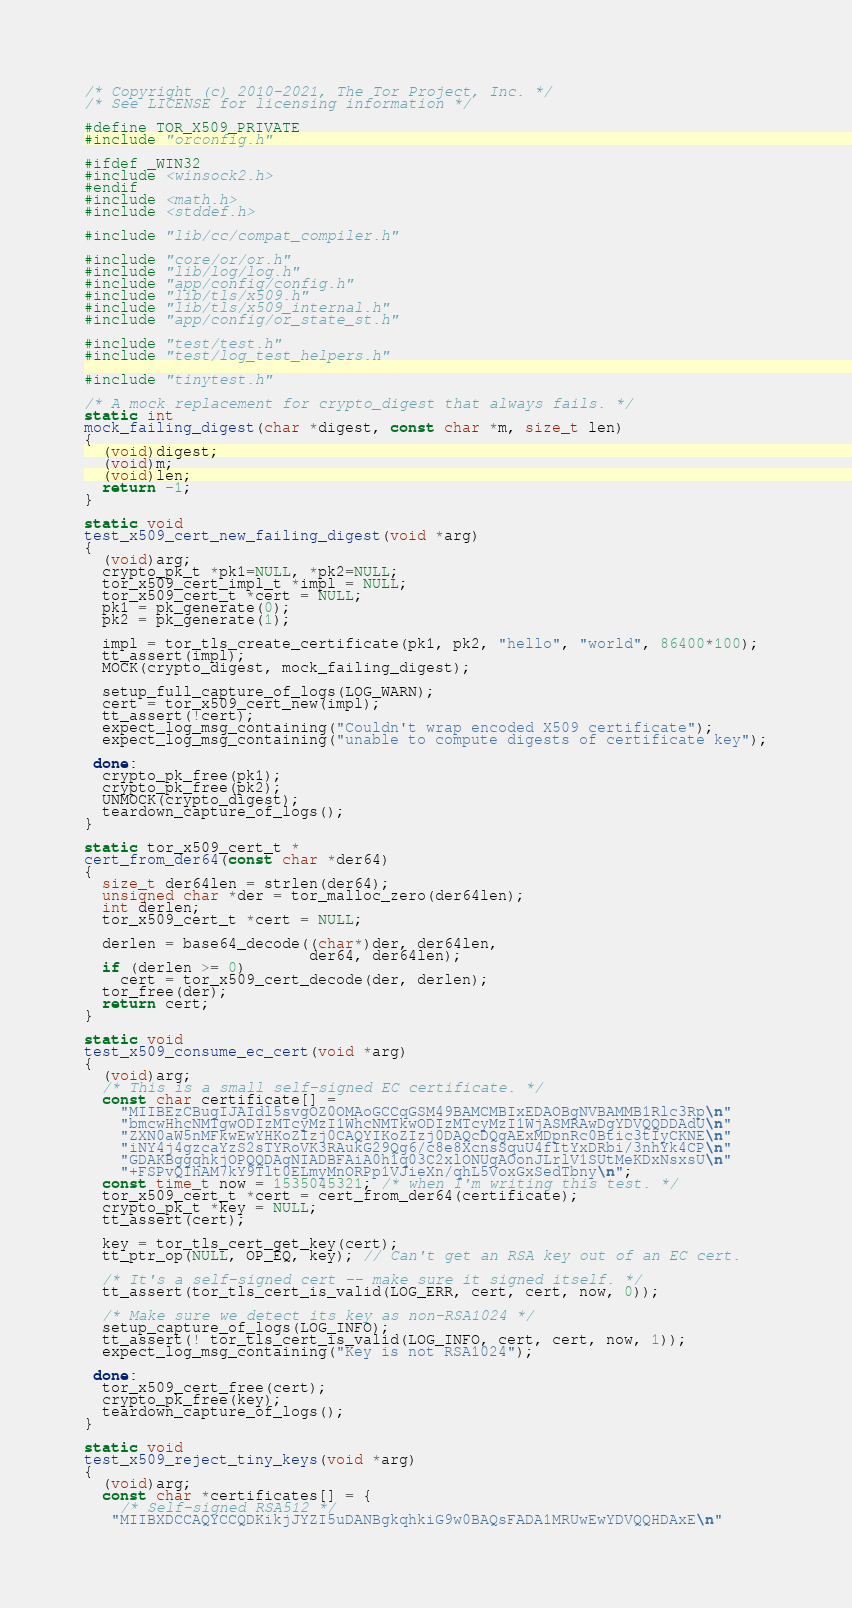Convert code to text. <code><loc_0><loc_0><loc_500><loc_500><_C_>/* Copyright (c) 2010-2021, The Tor Project, Inc. */
/* See LICENSE for licensing information */

#define TOR_X509_PRIVATE
#include "orconfig.h"

#ifdef _WIN32
#include <winsock2.h>
#endif
#include <math.h>
#include <stddef.h>

#include "lib/cc/compat_compiler.h"

#include "core/or/or.h"
#include "lib/log/log.h"
#include "app/config/config.h"
#include "lib/tls/x509.h"
#include "lib/tls/x509_internal.h"
#include "app/config/or_state_st.h"

#include "test/test.h"
#include "test/log_test_helpers.h"

#include "tinytest.h"

/* A mock replacement for crypto_digest that always fails. */
static int
mock_failing_digest(char *digest, const char *m, size_t len)
{
  (void)digest;
  (void)m;
  (void)len;
  return -1;
}

static void
test_x509_cert_new_failing_digest(void *arg)
{
  (void)arg;
  crypto_pk_t *pk1=NULL, *pk2=NULL;
  tor_x509_cert_impl_t *impl = NULL;
  tor_x509_cert_t *cert = NULL;
  pk1 = pk_generate(0);
  pk2 = pk_generate(1);

  impl = tor_tls_create_certificate(pk1, pk2, "hello", "world", 86400*100);
  tt_assert(impl);
  MOCK(crypto_digest, mock_failing_digest);

  setup_full_capture_of_logs(LOG_WARN);
  cert = tor_x509_cert_new(impl);
  tt_assert(!cert);
  expect_log_msg_containing("Couldn't wrap encoded X509 certificate");
  expect_log_msg_containing("unable to compute digests of certificate key");

 done:
  crypto_pk_free(pk1);
  crypto_pk_free(pk2);
  UNMOCK(crypto_digest);
  teardown_capture_of_logs();
}

static tor_x509_cert_t *
cert_from_der64(const char *der64)
{
  size_t der64len = strlen(der64);
  unsigned char *der = tor_malloc_zero(der64len);
  int derlen;
  tor_x509_cert_t *cert = NULL;

  derlen = base64_decode((char*)der, der64len,
                         der64, der64len);
  if (derlen >= 0)
    cert = tor_x509_cert_decode(der, derlen);
  tor_free(der);
  return cert;
}

static void
test_x509_consume_ec_cert(void *arg)
{
  (void)arg;
  /* This is a small self-signed EC certificate. */
  const char certificate[] =
    "MIIBEzCBugIJAIdl5svgOZ0OMAoGCCqGSM49BAMCMBIxEDAOBgNVBAMMB1Rlc3Rp\n"
    "bmcwHhcNMTgwODIzMTcyMzI1WhcNMTkwODIzMTcyMzI1WjASMRAwDgYDVQQDDAdU\n"
    "ZXN0aW5nMFkwEwYHKoZIzj0CAQYIKoZIzj0DAQcDQgAExMDpnRc0Btic3tIyCKNE\n"
    "iNY4j4gzcaYzS2sTYRoVK3RAukG29Qg6/c8e8XcnsSquU4fItYxDRbi/3nhYk4CP\n"
    "GDAKBggqhkjOPQQDAgNIADBFAiA0h1q03C2xlONUgAOonJLrlV1SUtMeKDxNsxsU\n"
    "+FSPvQIhAM7kY9Tlt0ELmyMnORPp1VJieXn/qhL5VoxGxSedTbny\n";
  const time_t now = 1535045321; /* when I'm writing this test. */
  tor_x509_cert_t *cert = cert_from_der64(certificate);
  crypto_pk_t *key = NULL;
  tt_assert(cert);

  key = tor_tls_cert_get_key(cert);
  tt_ptr_op(NULL, OP_EQ, key); // Can't get an RSA key out of an EC cert.

  /* It's a self-signed cert -- make sure it signed itself. */
  tt_assert(tor_tls_cert_is_valid(LOG_ERR, cert, cert, now, 0));

  /* Make sure we detect its key as non-RSA1024 */
  setup_capture_of_logs(LOG_INFO);
  tt_assert(! tor_tls_cert_is_valid(LOG_INFO, cert, cert, now, 1));
  expect_log_msg_containing("Key is not RSA1024");

 done:
  tor_x509_cert_free(cert);
  crypto_pk_free(key);
  teardown_capture_of_logs();
}

static void
test_x509_reject_tiny_keys(void *arg)
{
  (void)arg;
  const char *certificates[] = {
    /* Self-signed RSA512 */
   "MIIBXDCCAQYCCQDKikjJYZI5uDANBgkqhkiG9w0BAQsFADA1MRUwEwYDVQQHDAxE\n"</code> 